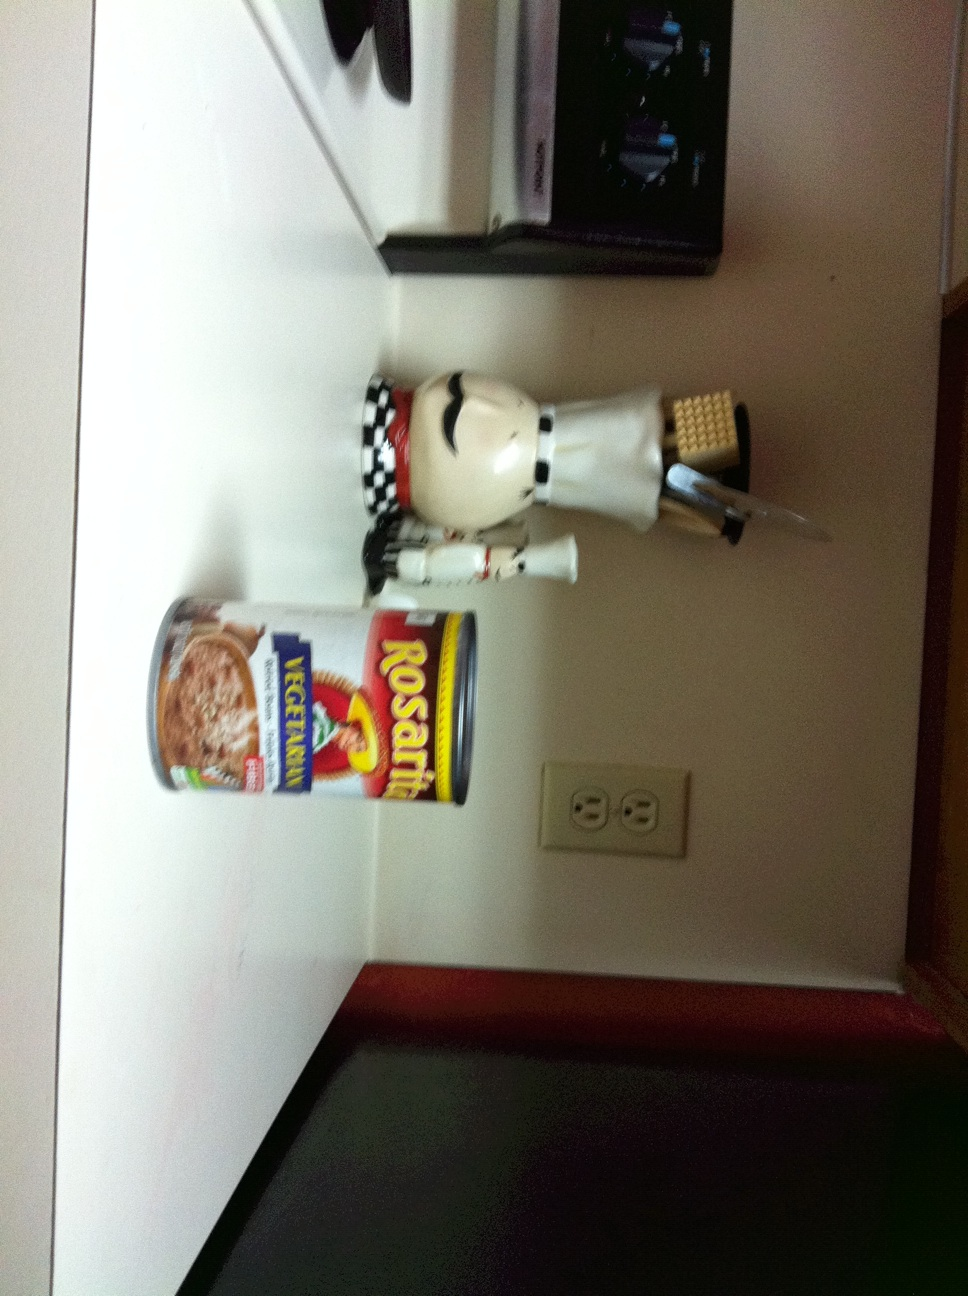What is the object next to the ice cream? The object next to the ice cream is a decorative chef statuette that appears to be holding cooking utensils. Could you tell me more about the product shown in the image? Certainly! The image shows a can of Rosarita Ice Cream, which is a dessert item. This brand is known for its Mexican style fried ice cream, blending a creamy texture with a crispy coating. 